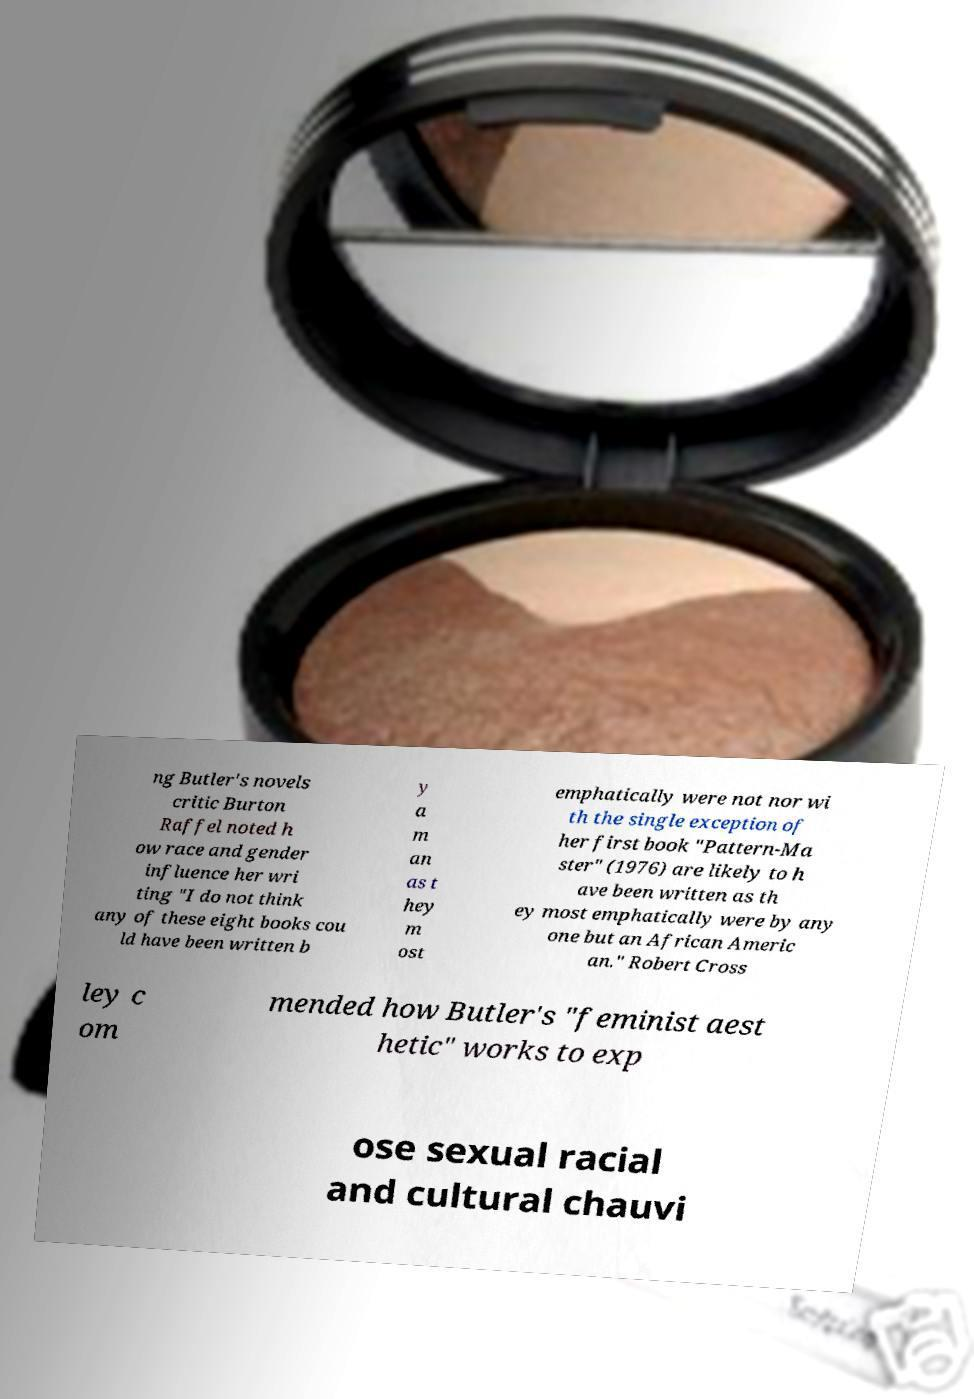There's text embedded in this image that I need extracted. Can you transcribe it verbatim? ng Butler's novels critic Burton Raffel noted h ow race and gender influence her wri ting "I do not think any of these eight books cou ld have been written b y a m an as t hey m ost emphatically were not nor wi th the single exception of her first book "Pattern-Ma ster" (1976) are likely to h ave been written as th ey most emphatically were by any one but an African Americ an." Robert Cross ley c om mended how Butler's "feminist aest hetic" works to exp ose sexual racial and cultural chauvi 